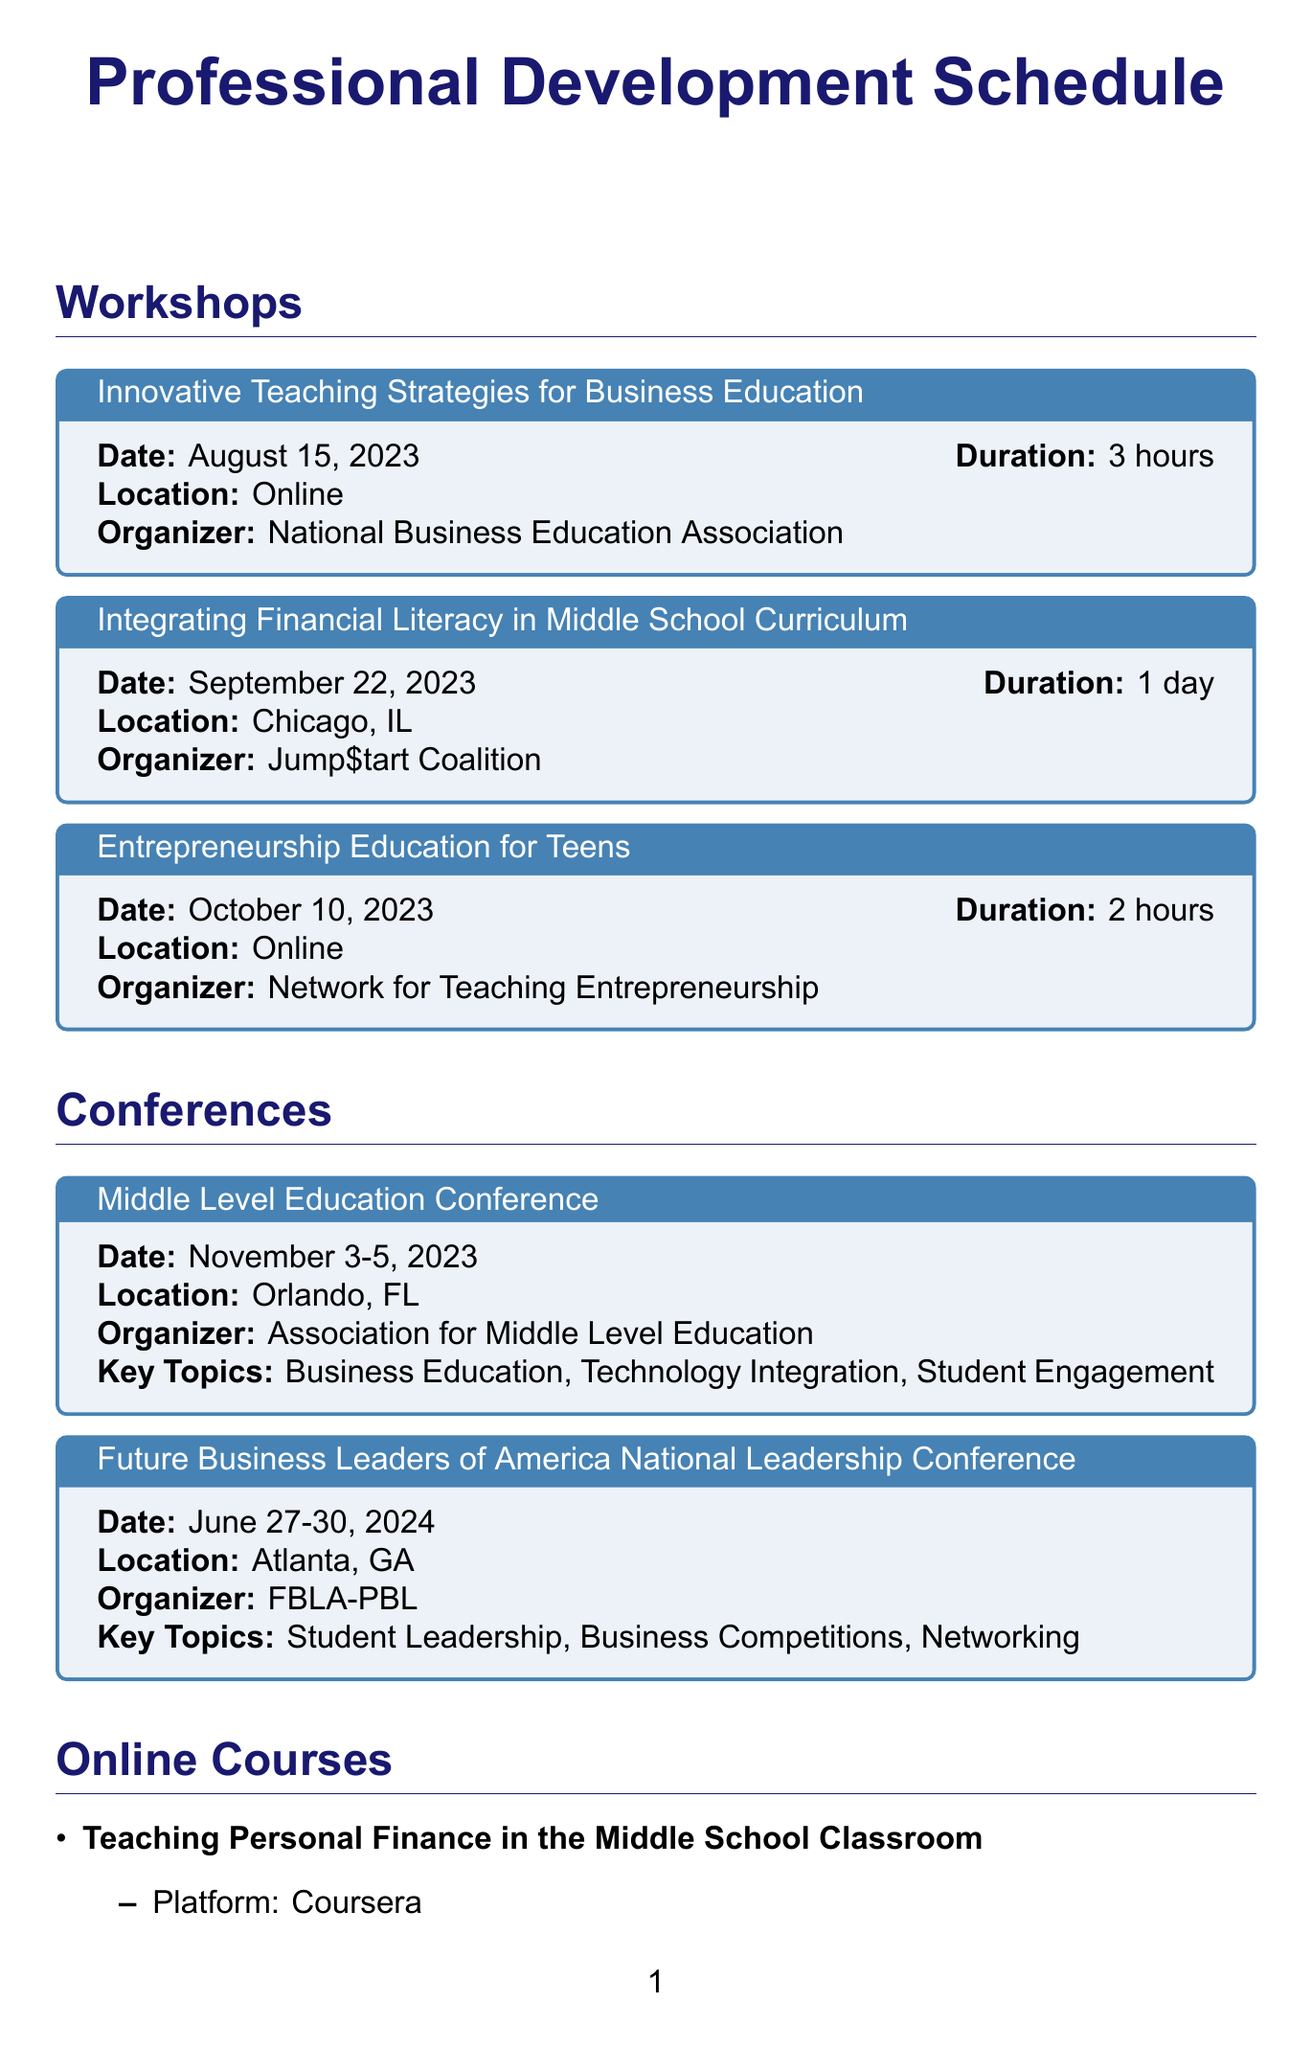What is the date of the "Integrating Financial Literacy in Middle School Curriculum" workshop? The date is specified in the document for each workshop, stating that it takes place on September 22, 2023.
Answer: September 22, 2023 Who is the organizer of the "Entrepreneurship Education for Teens" workshop? The document includes the organizer's name next to each workshop title, which is the Network for Teaching Entrepreneurship for this particular workshop.
Answer: Network for Teaching Entrepreneurship What is the duration of the "Middle Level Education Conference"? The document lists the duration of conferences, with this one running from November 3 to November 5, 2023.
Answer: 3 days Which online platform offers the course "Gamification in Business Education"? The document specifies the platform for each online course, noting that this particular course is offered on edX.
Answer: edX What are the key topics of the Future Business Leaders of America National Leadership Conference? The key topics are listed in the document under the conference details, which are Student Leadership, Business Competitions, and Networking.
Answer: Student Leadership, Business Competitions, Networking How much are the annual dues for the National Business Education Association? The dues are presented in a tabular format for each association; the document states that the annual dues are $85.
Answer: $85 When is the exam date for the Google Certified Educator Level 1 certification? The exam date is specified in the certification section, which states the exam is on December 10, 2023.
Answer: December 10, 2023 What is the start date for the online course on personal finance? The start date for the course is included in the document, indicating it begins on September 1, 2023.
Answer: September 1, 2023 How long is the "Teaching Personal Finance in the Middle School Classroom" course? The document provides the duration of each online course, which is noted as 4 weeks for this course.
Answer: 4 weeks 